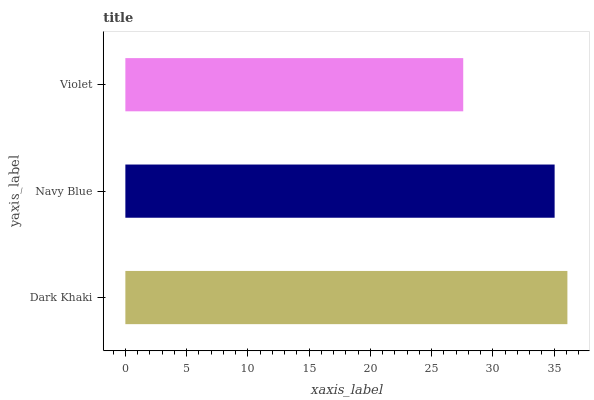Is Violet the minimum?
Answer yes or no. Yes. Is Dark Khaki the maximum?
Answer yes or no. Yes. Is Navy Blue the minimum?
Answer yes or no. No. Is Navy Blue the maximum?
Answer yes or no. No. Is Dark Khaki greater than Navy Blue?
Answer yes or no. Yes. Is Navy Blue less than Dark Khaki?
Answer yes or no. Yes. Is Navy Blue greater than Dark Khaki?
Answer yes or no. No. Is Dark Khaki less than Navy Blue?
Answer yes or no. No. Is Navy Blue the high median?
Answer yes or no. Yes. Is Navy Blue the low median?
Answer yes or no. Yes. Is Violet the high median?
Answer yes or no. No. Is Violet the low median?
Answer yes or no. No. 